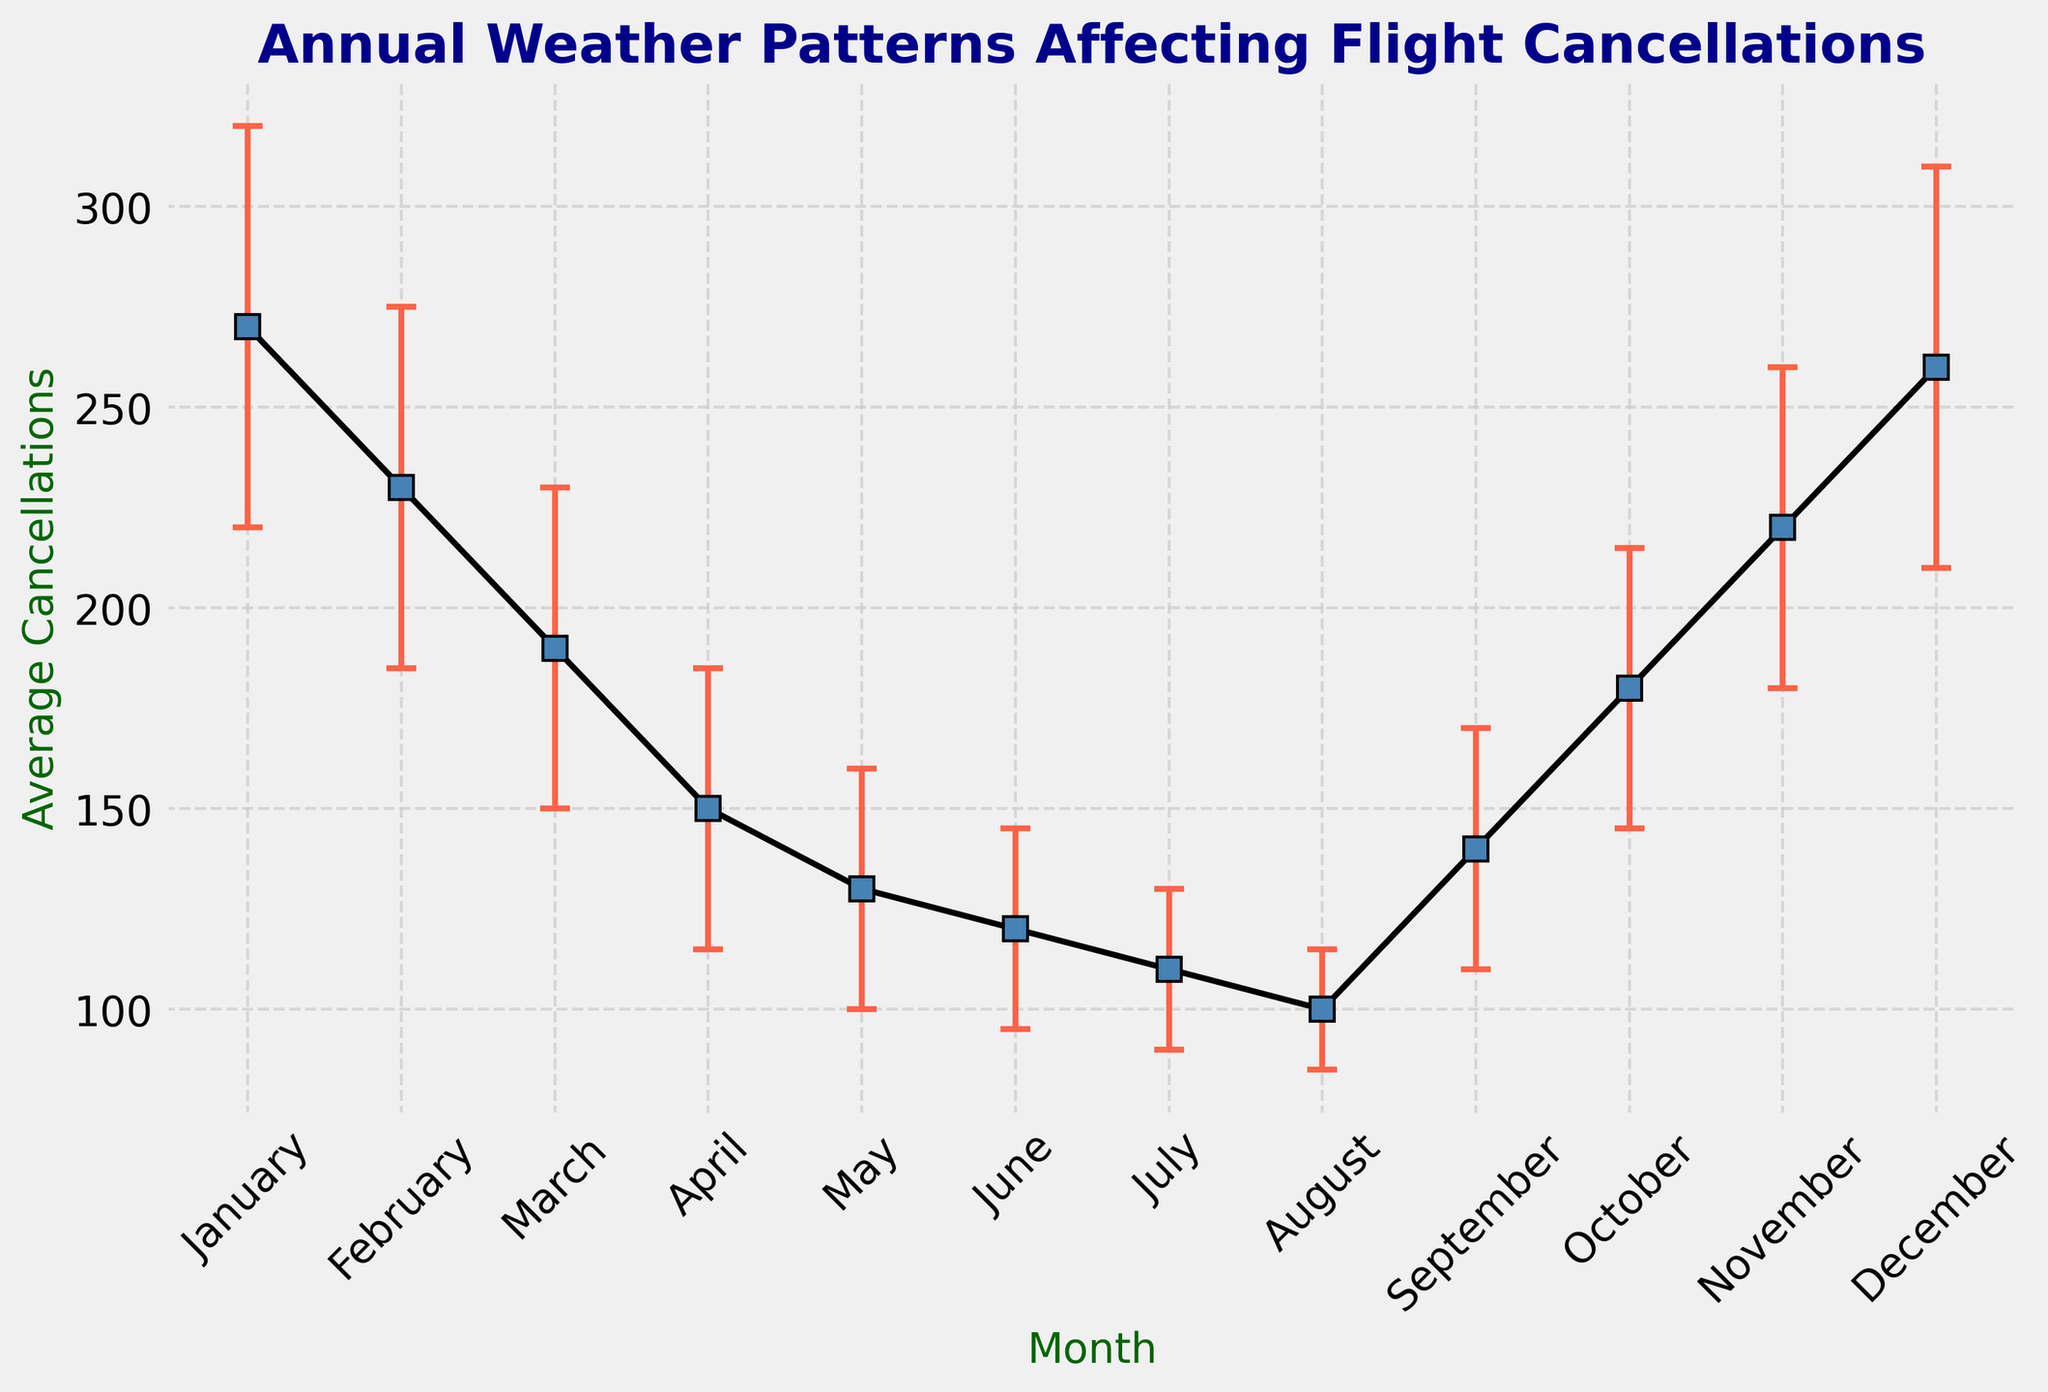Which month has the highest number of average flight cancellations? To determine the month with the highest average flight cancellations, refer to the y-axis values for each month on the plot. January has the highest value, signifying the highest average cancellations.
Answer: January What is the average number of flight cancellations in June? Find June on the x-axis and then look vertically to see where the June data point aligns on the y-axis. The value is 120.
Answer: 120 Which month has the smallest standard deviation in cancellations? Identify the months with the shortest error bars, as shorter error bars indicate smaller standard deviations. August has the shortest error bar.
Answer: August By how much does the average number of cancellations decrease from January to July? Locate January and July on the x-axis, and find their corresponding y-axis values (January: 270, July: 110). Subtract the two values (270 - 110).
Answer: 160 Are the average cancellations in December closer to those in January or November? Compare the y-axis values for December, January, and November. December (260) is closer to January (270) than November (220) when looking at the y-axis values.
Answer: January What is the range of the average cancellations from the month with the highest average to the month with the lowest average? Identify the highest and lowest y-axis values (January: 270, August: 100). Subtract the lowest from the highest (270 - 100).
Answer: 170 Which months have an average cancellations count above 200? Find the months where the y-axis values exceed 200. These months are January, February, November, and December.
Answer: January, February, November, December What is the difference in standard deviation between April and September? Compare the error bars for April and September (April: 35, September: 30). Subtract the standard deviations (35 - 30).
Answer: 5 What is the trend in average cancellations from June to September? Observe the y-axis values from June to September. This period shows a general increase from June (120) to September (140).
Answer: Increase How does the average cancellations in February compare to October? Compare the y-axis values for February (230) and October (180). February has higher average cancellations.
Answer: February 